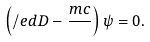Convert formula to latex. <formula><loc_0><loc_0><loc_500><loc_500>\left ( \slash e d { D } - \frac { m c } { } \right ) \psi = 0 .</formula> 